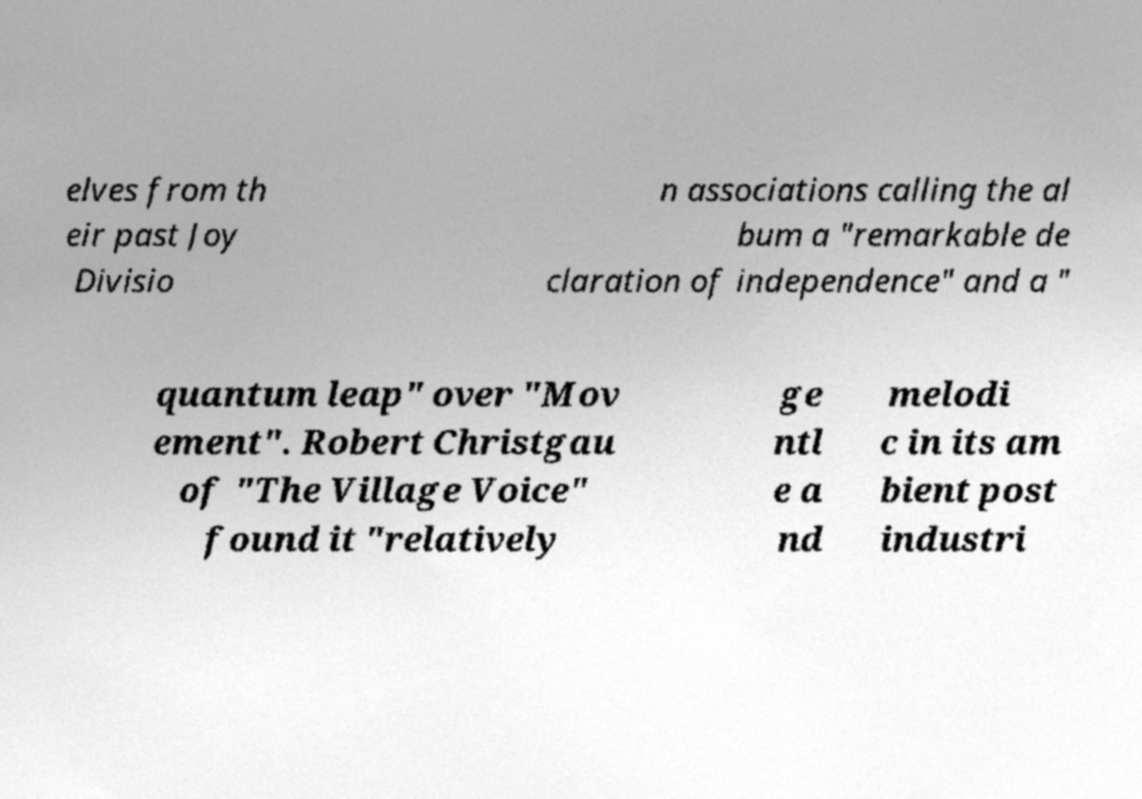There's text embedded in this image that I need extracted. Can you transcribe it verbatim? elves from th eir past Joy Divisio n associations calling the al bum a "remarkable de claration of independence" and a " quantum leap" over "Mov ement". Robert Christgau of "The Village Voice" found it "relatively ge ntl e a nd melodi c in its am bient post industri 